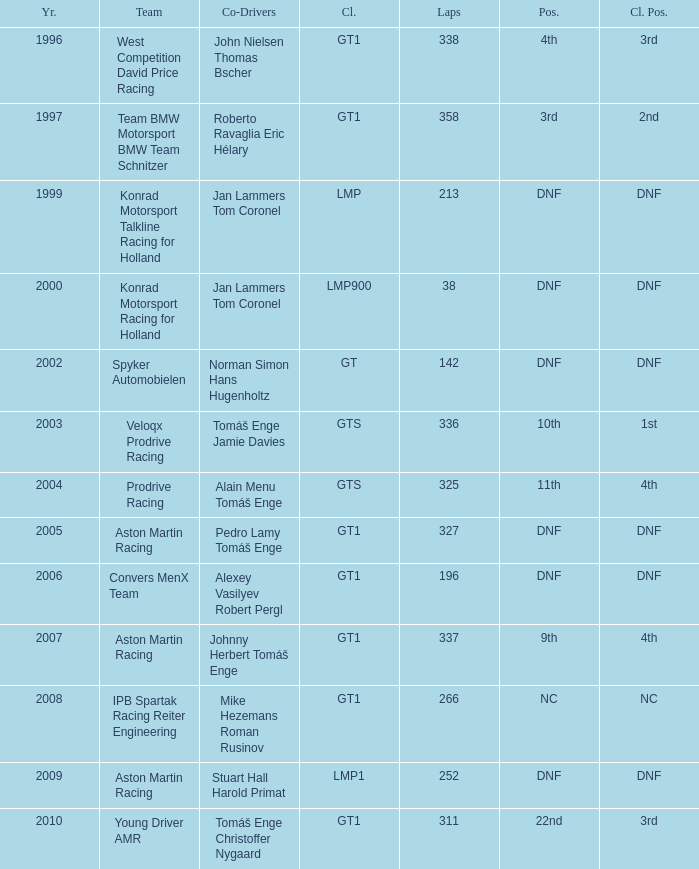Which spot concluded 3rd in the course and finished under 338 laps? 22nd. 